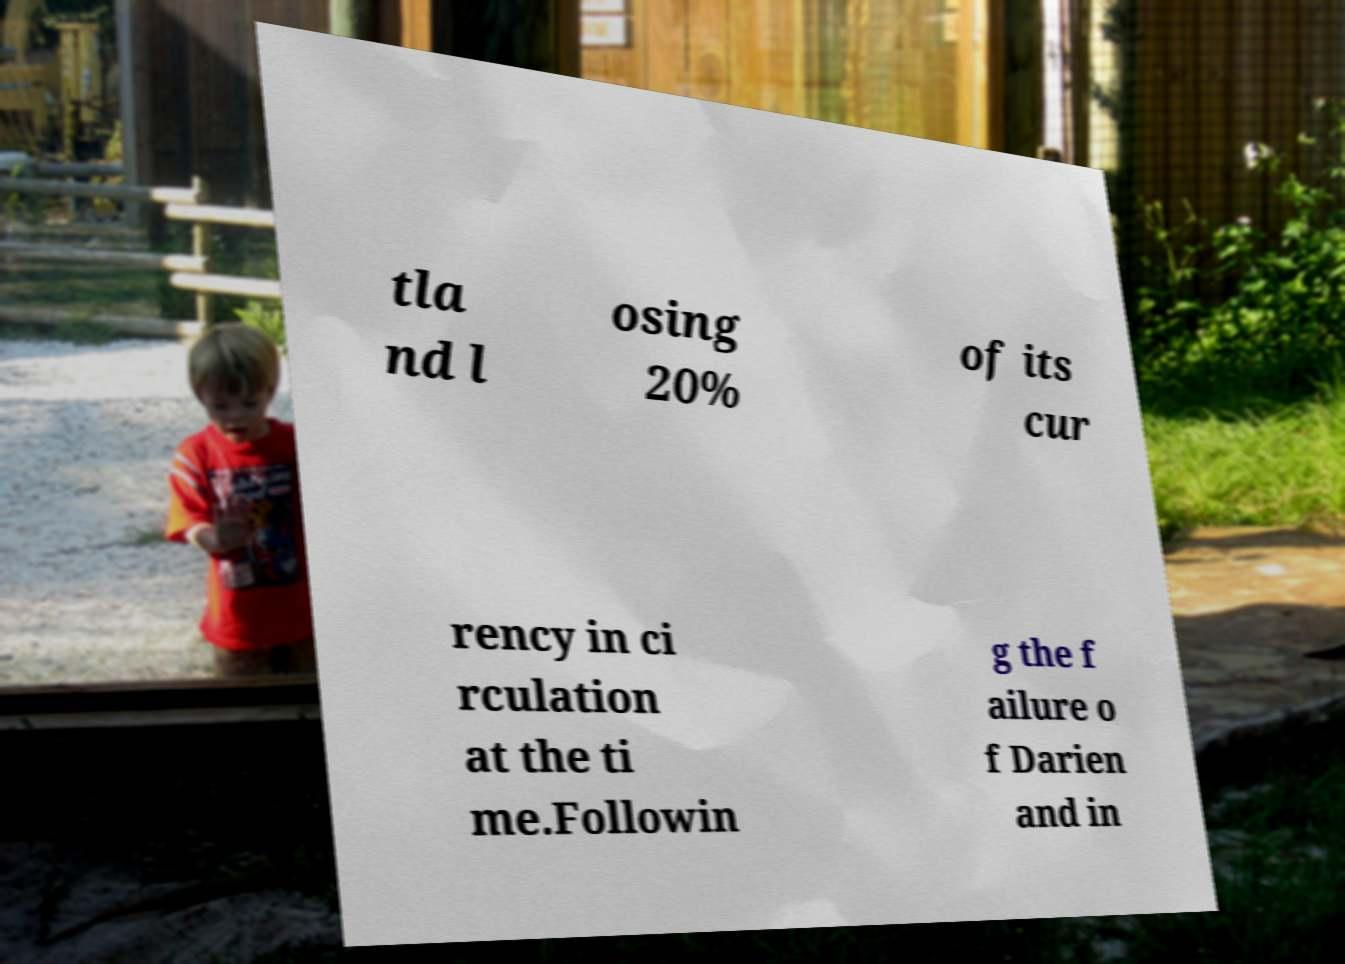Can you read and provide the text displayed in the image?This photo seems to have some interesting text. Can you extract and type it out for me? tla nd l osing 20% of its cur rency in ci rculation at the ti me.Followin g the f ailure o f Darien and in 